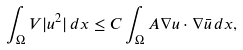Convert formula to latex. <formula><loc_0><loc_0><loc_500><loc_500>\int _ { \Omega } V | u ^ { 2 } | \, d x \leq C \int _ { \Omega } A \nabla u \cdot \nabla \bar { u } \, d x ,</formula> 